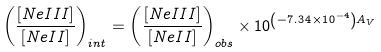Convert formula to latex. <formula><loc_0><loc_0><loc_500><loc_500>\left ( \frac { [ N e I I I ] } { [ N e I I ] } \right ) _ { i n t } = \left ( \frac { [ N e I I I ] } { [ N e I I ] } \right ) _ { o b s } \times 1 0 ^ { \left ( - 7 . 3 4 \times 1 0 ^ { - 4 } \right ) A _ { V } }</formula> 